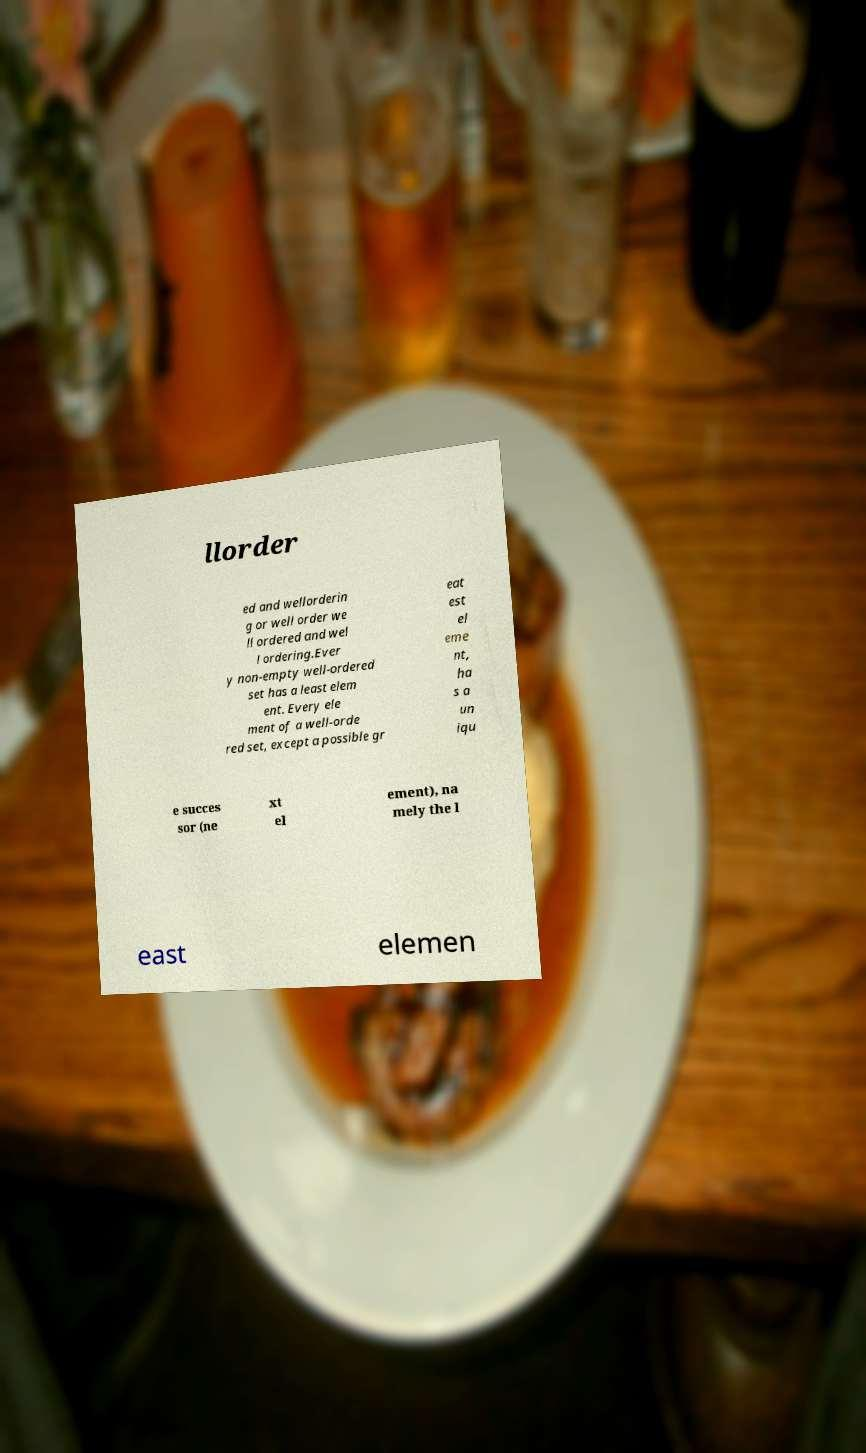Please read and relay the text visible in this image. What does it say? llorder ed and wellorderin g or well order we ll ordered and wel l ordering.Ever y non-empty well-ordered set has a least elem ent. Every ele ment of a well-orde red set, except a possible gr eat est el eme nt, ha s a un iqu e succes sor (ne xt el ement), na mely the l east elemen 